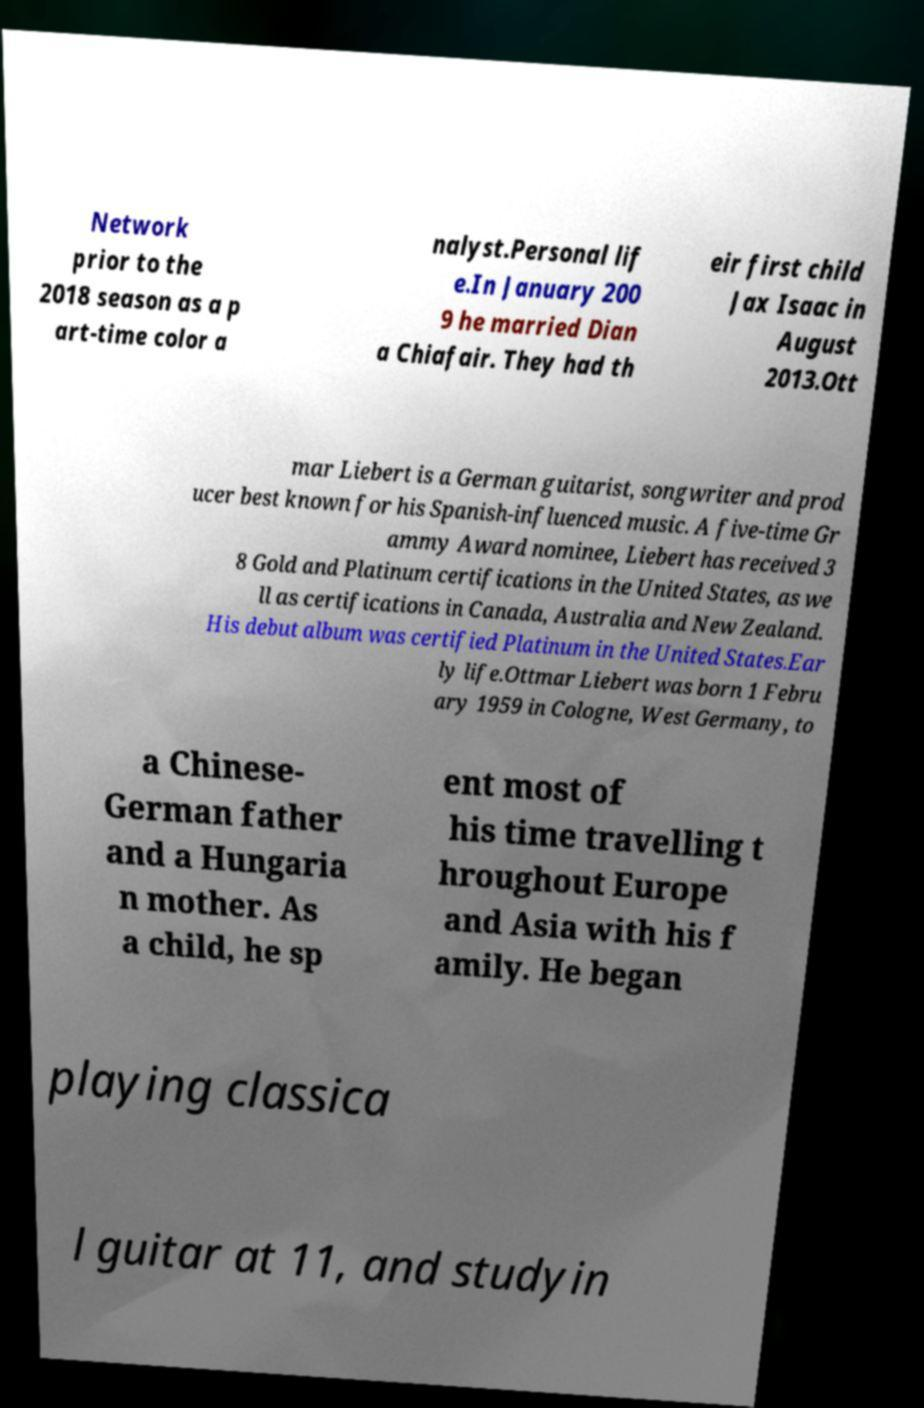Could you extract and type out the text from this image? Network prior to the 2018 season as a p art-time color a nalyst.Personal lif e.In January 200 9 he married Dian a Chiafair. They had th eir first child Jax Isaac in August 2013.Ott mar Liebert is a German guitarist, songwriter and prod ucer best known for his Spanish-influenced music. A five-time Gr ammy Award nominee, Liebert has received 3 8 Gold and Platinum certifications in the United States, as we ll as certifications in Canada, Australia and New Zealand. His debut album was certified Platinum in the United States.Ear ly life.Ottmar Liebert was born 1 Febru ary 1959 in Cologne, West Germany, to a Chinese- German father and a Hungaria n mother. As a child, he sp ent most of his time travelling t hroughout Europe and Asia with his f amily. He began playing classica l guitar at 11, and studyin 